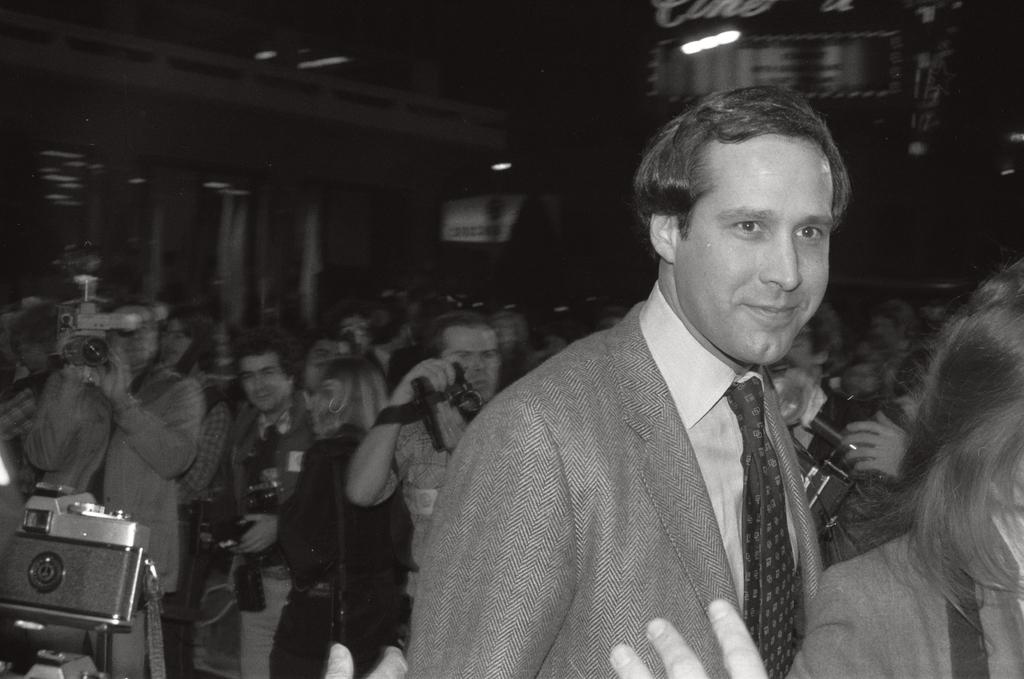What is the main subject of the image? The main subject of the image is a group of people. What are some of the people in the image doing? Some of the people are standing, while others are holding cameras in their hands. What type of quarter is visible in the image? There is no quarter present in the image. What is the order of the people in the image? The image does not show the people in any specific order. 